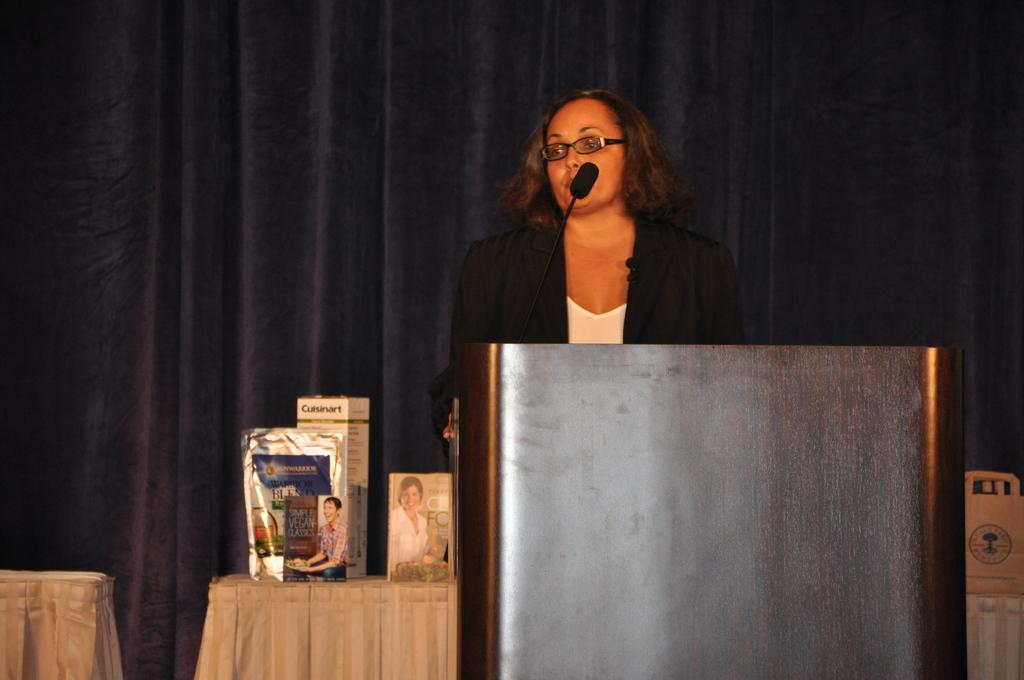Who is the main subject in the image? There is a woman in the image. What is the woman doing in the image? The woman is standing and talking in front of a microphone. What objects can be seen on a table in the image? There are boxes on a table in the image. What can be seen in the background of the image? There is a curtain visible in the background of the image. Are there any cobwebs visible on the woman's face in the image? There are no cobwebs visible on the woman's face in the image. What achievement has the woman won that is being celebrated in the image? The image does not provide information about any achievements or celebrations; it simply shows a woman standing and talking in front of a microphone. 